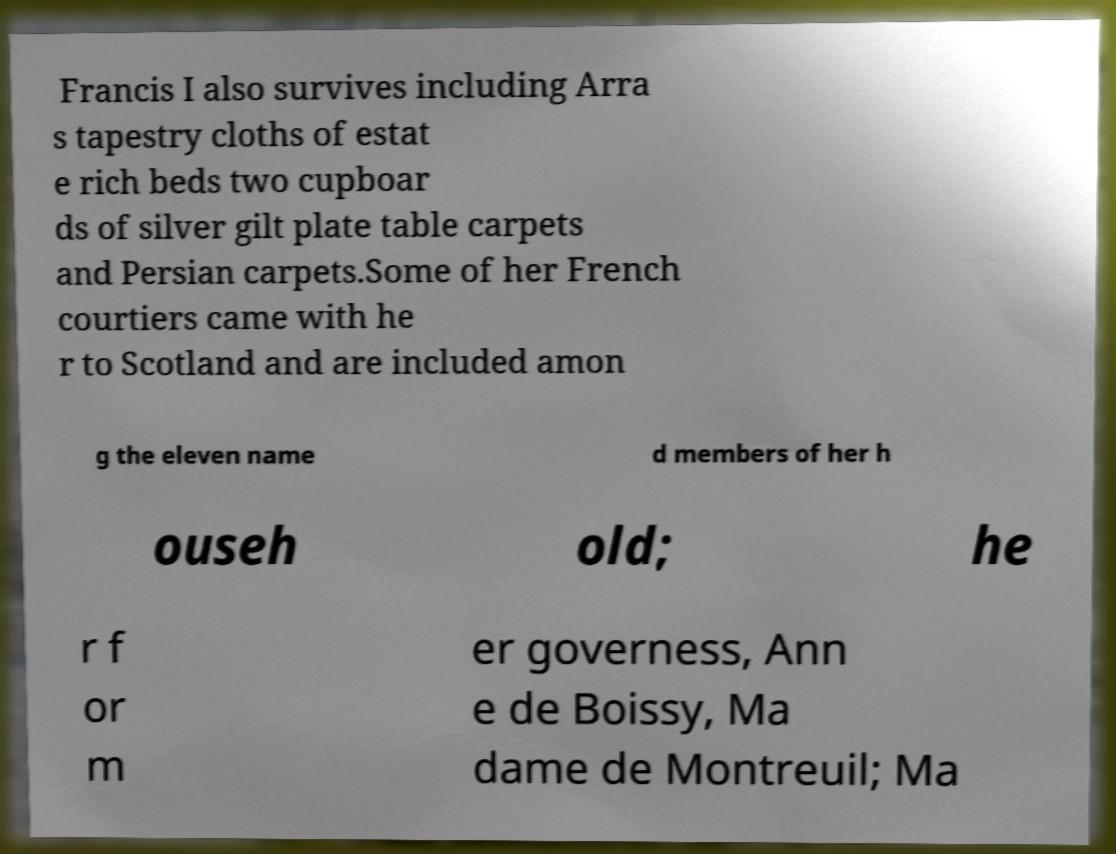There's text embedded in this image that I need extracted. Can you transcribe it verbatim? Francis I also survives including Arra s tapestry cloths of estat e rich beds two cupboar ds of silver gilt plate table carpets and Persian carpets.Some of her French courtiers came with he r to Scotland and are included amon g the eleven name d members of her h ouseh old; he r f or m er governess, Ann e de Boissy, Ma dame de Montreuil; Ma 